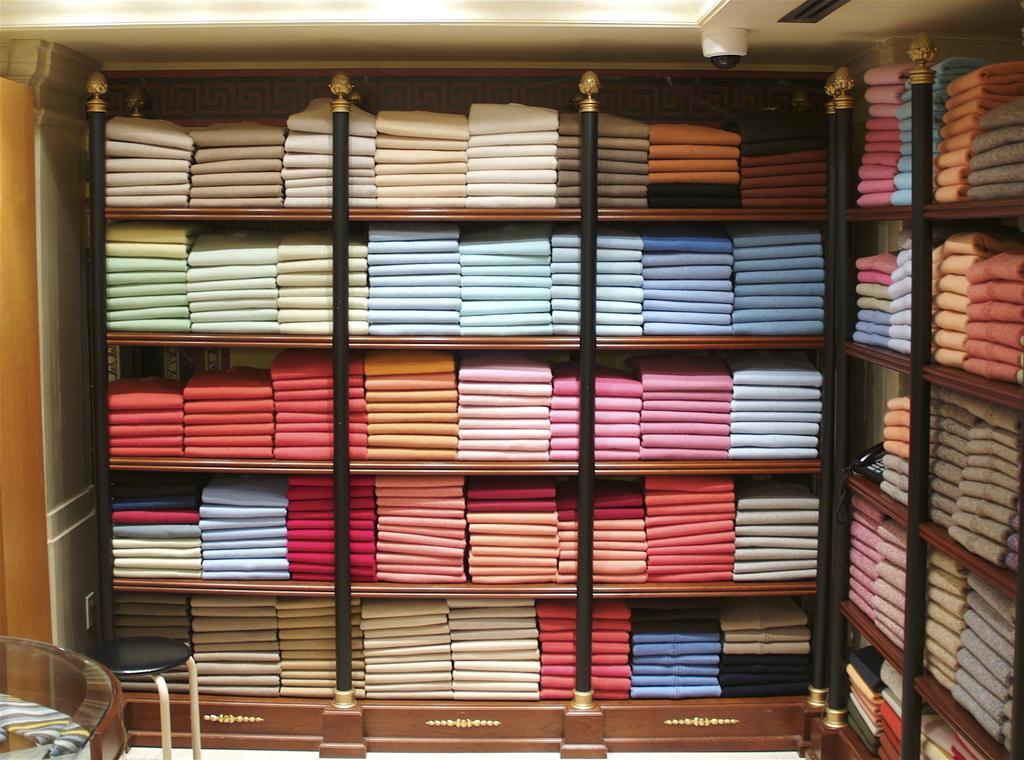Could you give a brief overview of what you see in this image? This picture shows few clothes in the shelves and we see a stool and a glass table on the side and we see lights to the ceiling. 